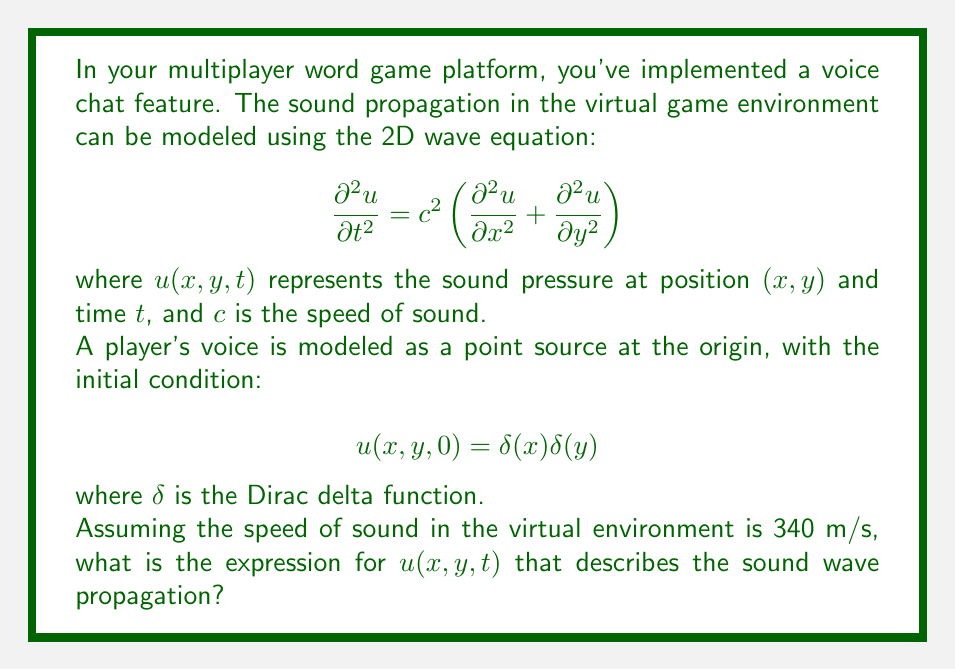Could you help me with this problem? To solve this problem, we need to use the fundamental solution of the 2D wave equation, also known as the Green's function. The steps are as follows:

1) The general solution for the 2D wave equation with a point source initial condition is given by:

   $$u(x,y,t) = \frac{1}{2\pi c^2t} \frac{H(ct - r)}{\sqrt{c^2t^2 - r^2}}$$

   where $H$ is the Heaviside step function, and $r = \sqrt{x^2 + y^2}$ is the distance from the origin.

2) The Heaviside step function $H(ct - r)$ ensures that the solution is zero outside the expanding circular wavefront.

3) We're given that the speed of sound $c = 340$ m/s. Substituting this into our general solution:

   $$u(x,y,t) = \frac{1}{2\pi (340)^2t} \frac{H(340t - \sqrt{x^2 + y^2})}{\sqrt{(340t)^2 - (x^2 + y^2)}}$$

4) Simplifying the constants:

   $$u(x,y,t) = \frac{1}{725760\pi t} \frac{H(340t - \sqrt{x^2 + y^2})}{\sqrt{115600t^2 - (x^2 + y^2)}}$$

This expression describes how the sound pressure $u$ varies with position $(x,y)$ and time $t$ in your virtual game environment.
Answer: $$u(x,y,t) = \frac{1}{725760\pi t} \frac{H(340t - \sqrt{x^2 + y^2})}{\sqrt{115600t^2 - (x^2 + y^2)}}$$ 